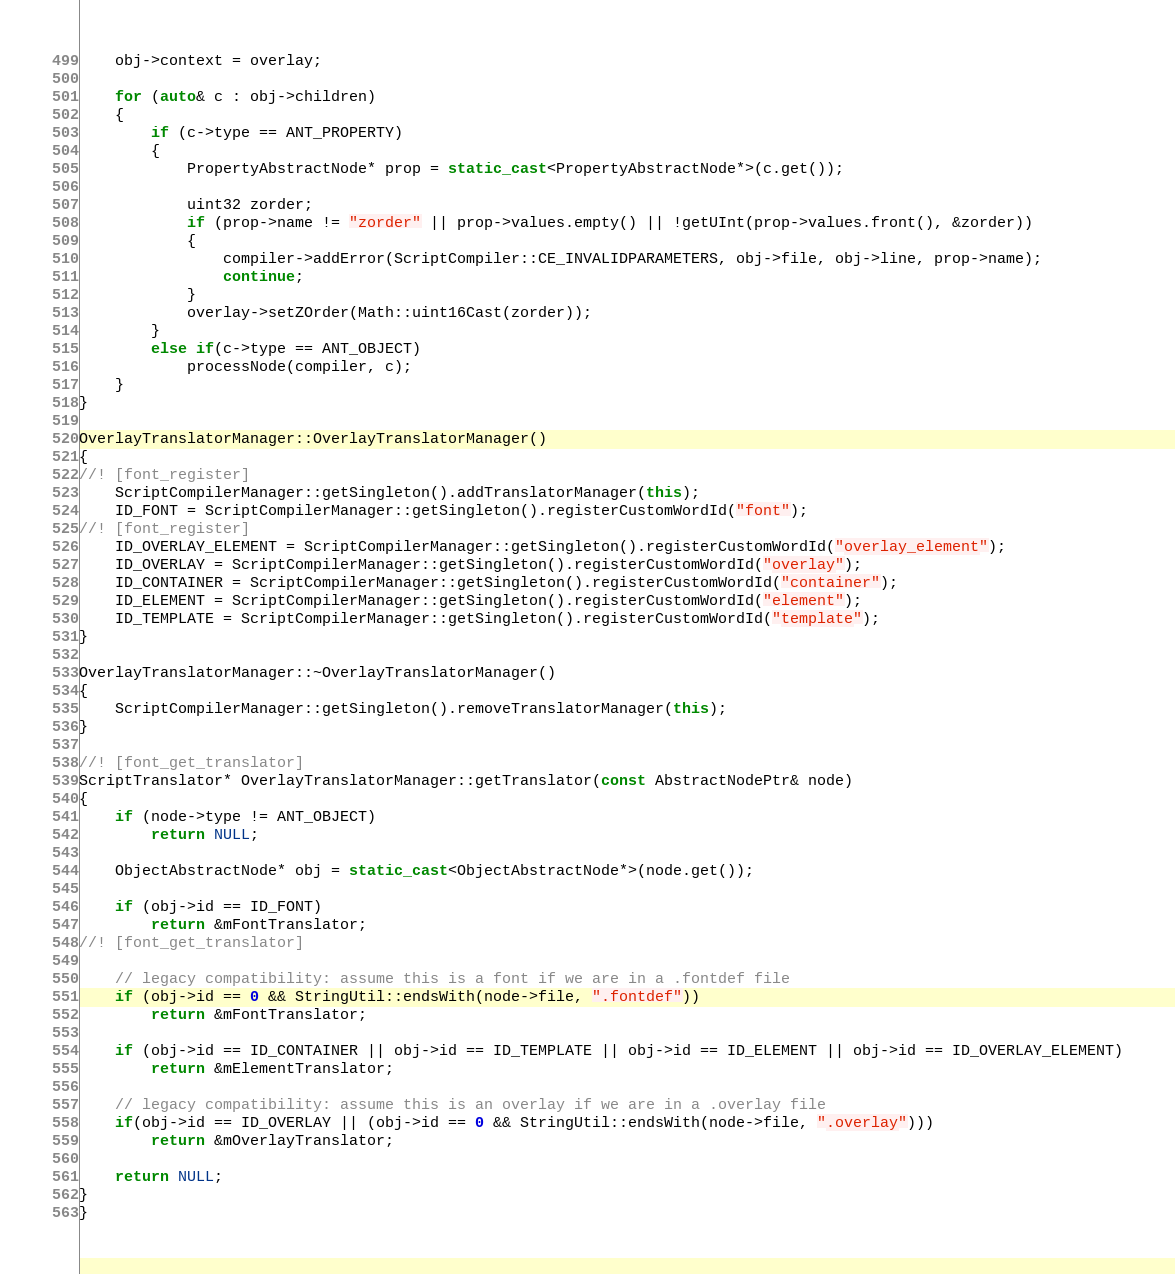<code> <loc_0><loc_0><loc_500><loc_500><_C++_>    obj->context = overlay;

    for (auto& c : obj->children)
    {
        if (c->type == ANT_PROPERTY)
        {
            PropertyAbstractNode* prop = static_cast<PropertyAbstractNode*>(c.get());

            uint32 zorder;
            if (prop->name != "zorder" || prop->values.empty() || !getUInt(prop->values.front(), &zorder))
            {
                compiler->addError(ScriptCompiler::CE_INVALIDPARAMETERS, obj->file, obj->line, prop->name);
                continue;
            }
            overlay->setZOrder(Math::uint16Cast(zorder));
        }
        else if(c->type == ANT_OBJECT)
            processNode(compiler, c);
    }
}

OverlayTranslatorManager::OverlayTranslatorManager()
{
//! [font_register]
    ScriptCompilerManager::getSingleton().addTranslatorManager(this);
    ID_FONT = ScriptCompilerManager::getSingleton().registerCustomWordId("font");
//! [font_register]
    ID_OVERLAY_ELEMENT = ScriptCompilerManager::getSingleton().registerCustomWordId("overlay_element");
    ID_OVERLAY = ScriptCompilerManager::getSingleton().registerCustomWordId("overlay");
    ID_CONTAINER = ScriptCompilerManager::getSingleton().registerCustomWordId("container");
    ID_ELEMENT = ScriptCompilerManager::getSingleton().registerCustomWordId("element");
    ID_TEMPLATE = ScriptCompilerManager::getSingleton().registerCustomWordId("template");
}

OverlayTranslatorManager::~OverlayTranslatorManager()
{
    ScriptCompilerManager::getSingleton().removeTranslatorManager(this);
}

//! [font_get_translator]
ScriptTranslator* OverlayTranslatorManager::getTranslator(const AbstractNodePtr& node)
{
    if (node->type != ANT_OBJECT)
        return NULL;

    ObjectAbstractNode* obj = static_cast<ObjectAbstractNode*>(node.get());

    if (obj->id == ID_FONT)
        return &mFontTranslator;
//! [font_get_translator]

    // legacy compatibility: assume this is a font if we are in a .fontdef file
    if (obj->id == 0 && StringUtil::endsWith(node->file, ".fontdef"))
        return &mFontTranslator;

    if (obj->id == ID_CONTAINER || obj->id == ID_TEMPLATE || obj->id == ID_ELEMENT || obj->id == ID_OVERLAY_ELEMENT)
        return &mElementTranslator;

    // legacy compatibility: assume this is an overlay if we are in a .overlay file
    if(obj->id == ID_OVERLAY || (obj->id == 0 && StringUtil::endsWith(node->file, ".overlay")))
        return &mOverlayTranslator;

    return NULL;
}
}
</code> 